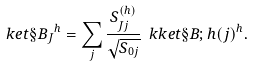<formula> <loc_0><loc_0><loc_500><loc_500>\ k e t { \S B _ { J } } ^ { h } = \sum _ { j } \frac { S ^ { ( h ) } _ { J j } } { \sqrt { S _ { 0 j } } } \ k k e t { \S B ; h ( j ) } ^ { h } .</formula> 